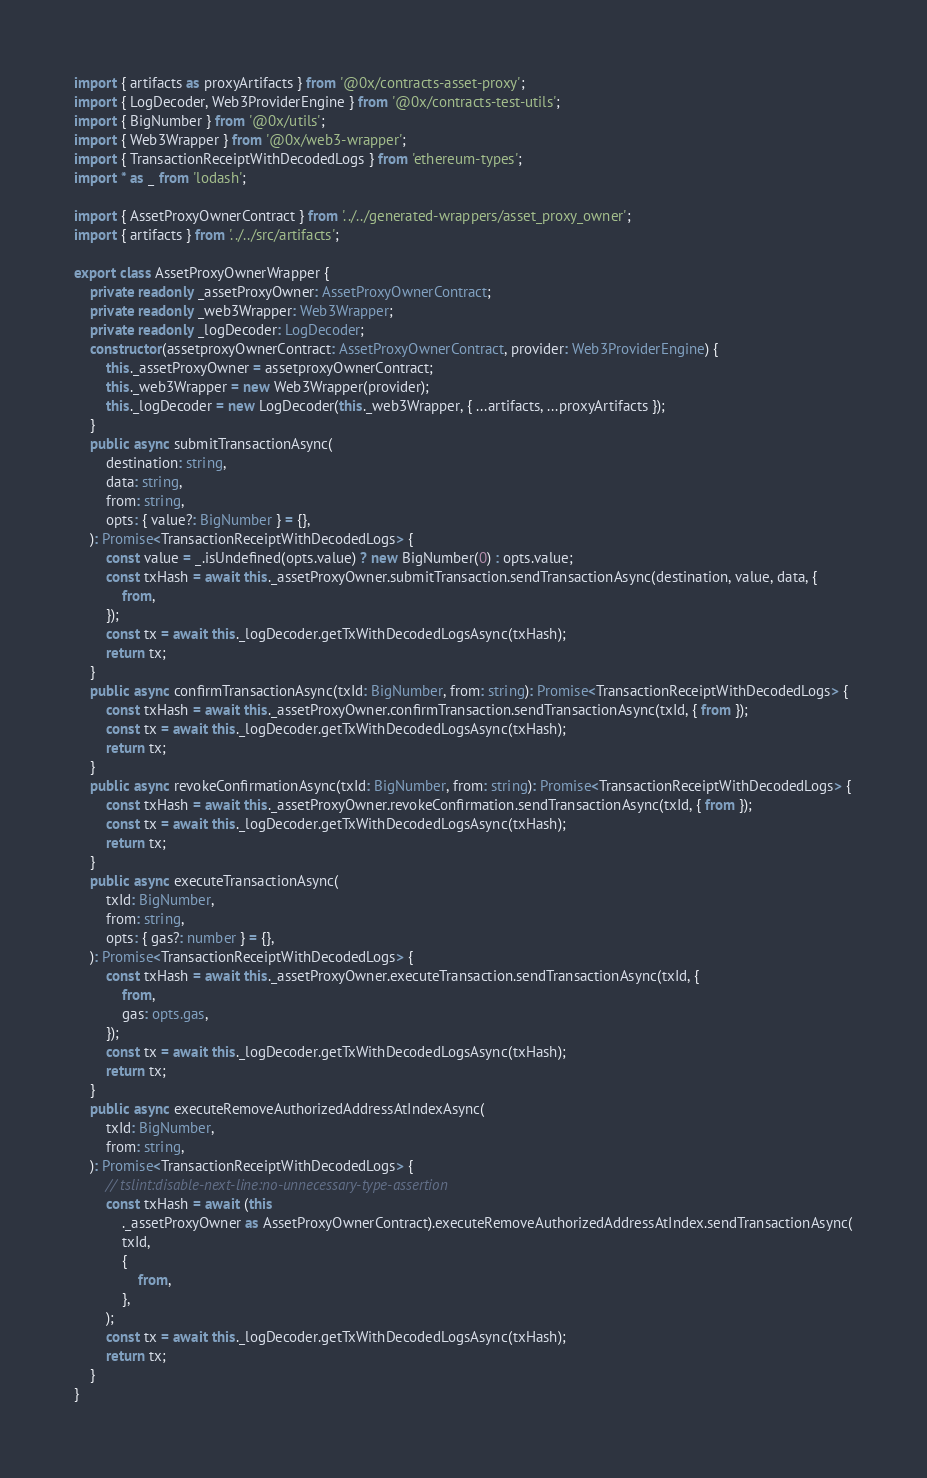<code> <loc_0><loc_0><loc_500><loc_500><_TypeScript_>import { artifacts as proxyArtifacts } from '@0x/contracts-asset-proxy';
import { LogDecoder, Web3ProviderEngine } from '@0x/contracts-test-utils';
import { BigNumber } from '@0x/utils';
import { Web3Wrapper } from '@0x/web3-wrapper';
import { TransactionReceiptWithDecodedLogs } from 'ethereum-types';
import * as _ from 'lodash';

import { AssetProxyOwnerContract } from '../../generated-wrappers/asset_proxy_owner';
import { artifacts } from '../../src/artifacts';

export class AssetProxyOwnerWrapper {
    private readonly _assetProxyOwner: AssetProxyOwnerContract;
    private readonly _web3Wrapper: Web3Wrapper;
    private readonly _logDecoder: LogDecoder;
    constructor(assetproxyOwnerContract: AssetProxyOwnerContract, provider: Web3ProviderEngine) {
        this._assetProxyOwner = assetproxyOwnerContract;
        this._web3Wrapper = new Web3Wrapper(provider);
        this._logDecoder = new LogDecoder(this._web3Wrapper, { ...artifacts, ...proxyArtifacts });
    }
    public async submitTransactionAsync(
        destination: string,
        data: string,
        from: string,
        opts: { value?: BigNumber } = {},
    ): Promise<TransactionReceiptWithDecodedLogs> {
        const value = _.isUndefined(opts.value) ? new BigNumber(0) : opts.value;
        const txHash = await this._assetProxyOwner.submitTransaction.sendTransactionAsync(destination, value, data, {
            from,
        });
        const tx = await this._logDecoder.getTxWithDecodedLogsAsync(txHash);
        return tx;
    }
    public async confirmTransactionAsync(txId: BigNumber, from: string): Promise<TransactionReceiptWithDecodedLogs> {
        const txHash = await this._assetProxyOwner.confirmTransaction.sendTransactionAsync(txId, { from });
        const tx = await this._logDecoder.getTxWithDecodedLogsAsync(txHash);
        return tx;
    }
    public async revokeConfirmationAsync(txId: BigNumber, from: string): Promise<TransactionReceiptWithDecodedLogs> {
        const txHash = await this._assetProxyOwner.revokeConfirmation.sendTransactionAsync(txId, { from });
        const tx = await this._logDecoder.getTxWithDecodedLogsAsync(txHash);
        return tx;
    }
    public async executeTransactionAsync(
        txId: BigNumber,
        from: string,
        opts: { gas?: number } = {},
    ): Promise<TransactionReceiptWithDecodedLogs> {
        const txHash = await this._assetProxyOwner.executeTransaction.sendTransactionAsync(txId, {
            from,
            gas: opts.gas,
        });
        const tx = await this._logDecoder.getTxWithDecodedLogsAsync(txHash);
        return tx;
    }
    public async executeRemoveAuthorizedAddressAtIndexAsync(
        txId: BigNumber,
        from: string,
    ): Promise<TransactionReceiptWithDecodedLogs> {
        // tslint:disable-next-line:no-unnecessary-type-assertion
        const txHash = await (this
            ._assetProxyOwner as AssetProxyOwnerContract).executeRemoveAuthorizedAddressAtIndex.sendTransactionAsync(
            txId,
            {
                from,
            },
        );
        const tx = await this._logDecoder.getTxWithDecodedLogsAsync(txHash);
        return tx;
    }
}
</code> 